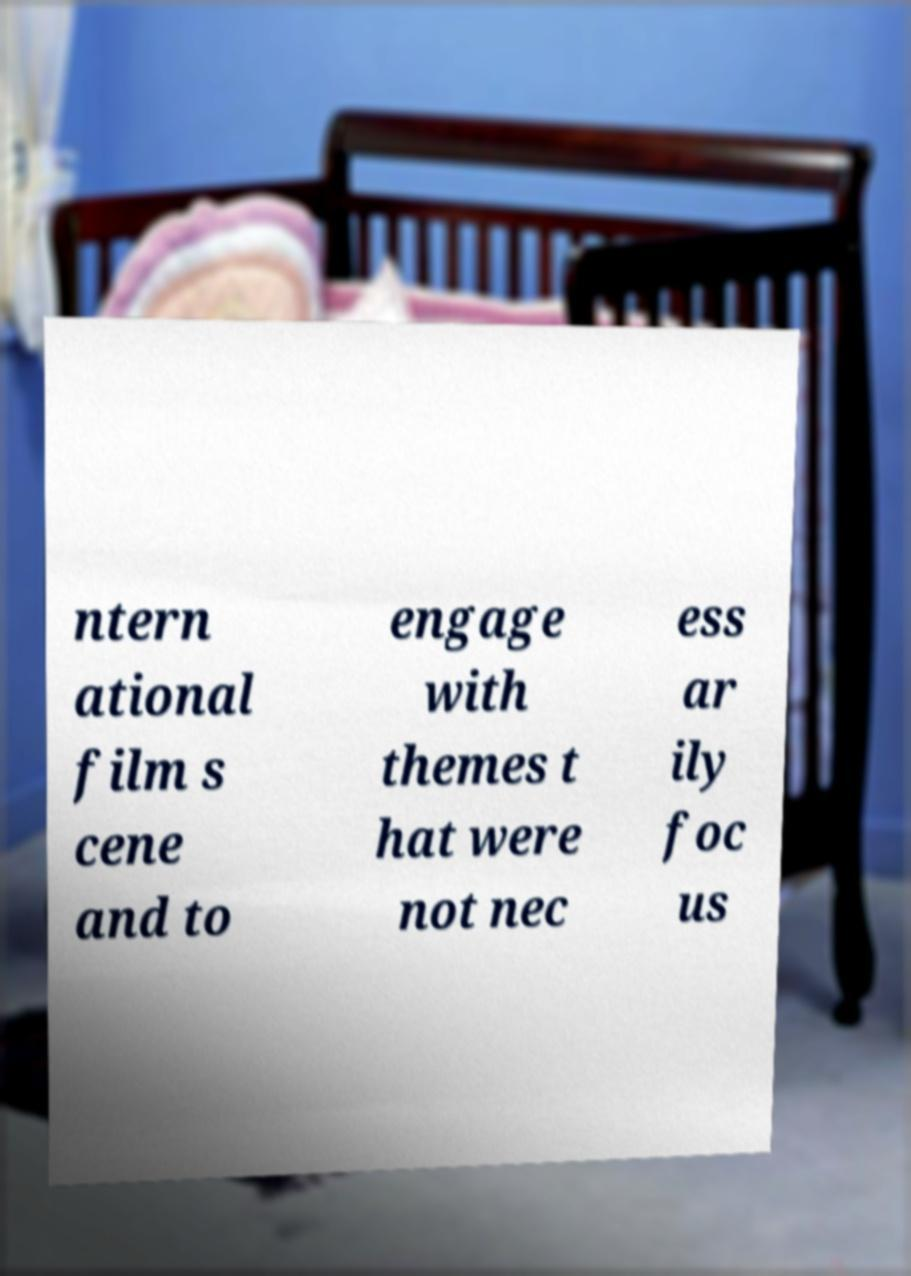For documentation purposes, I need the text within this image transcribed. Could you provide that? ntern ational film s cene and to engage with themes t hat were not nec ess ar ily foc us 